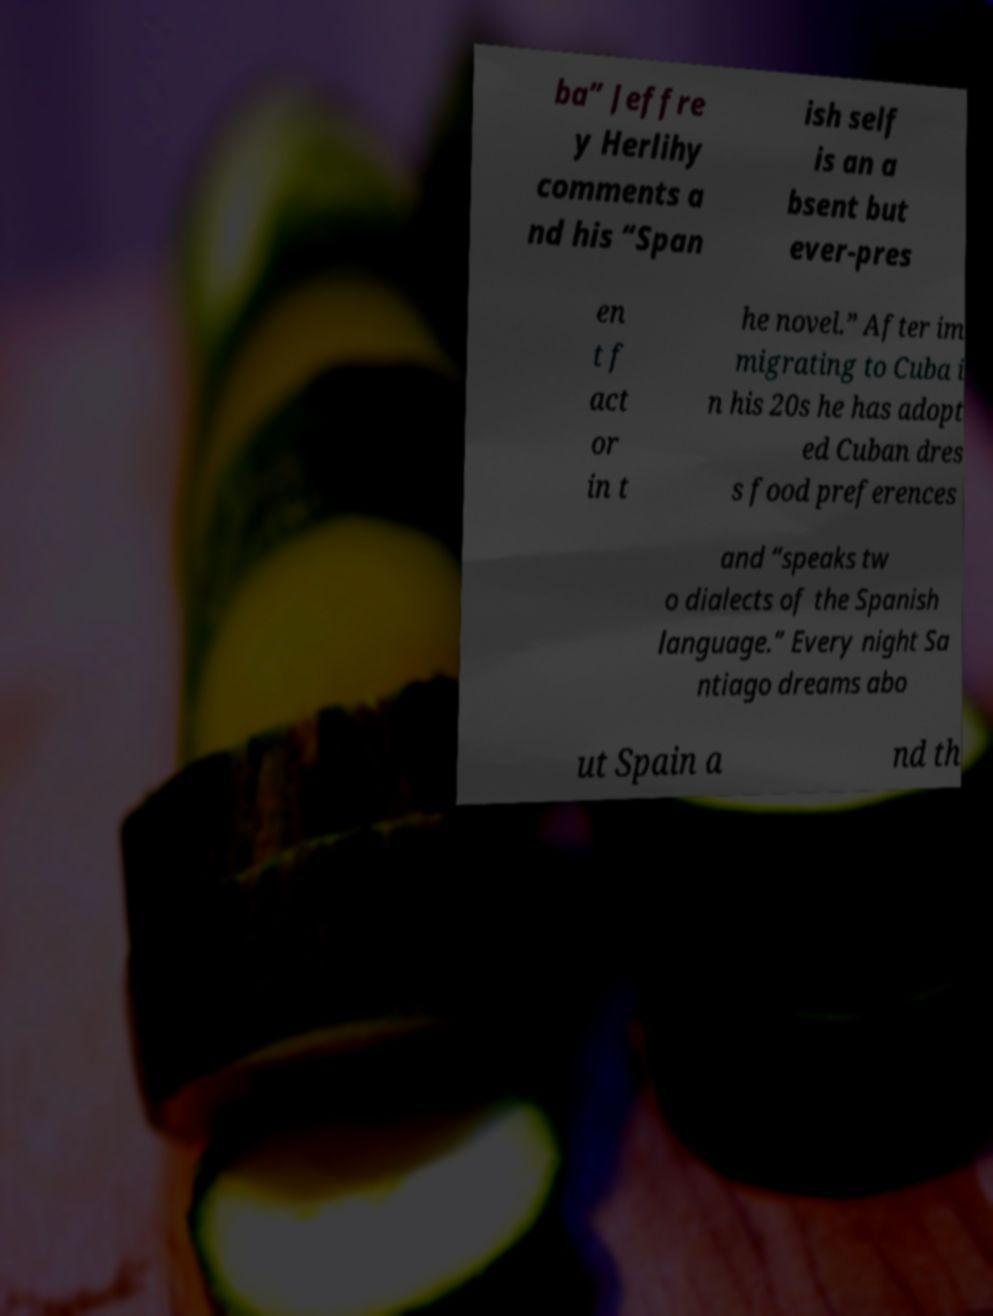What messages or text are displayed in this image? I need them in a readable, typed format. ba” Jeffre y Herlihy comments a nd his “Span ish self is an a bsent but ever-pres en t f act or in t he novel.” After im migrating to Cuba i n his 20s he has adopt ed Cuban dres s food preferences and “speaks tw o dialects of the Spanish language.” Every night Sa ntiago dreams abo ut Spain a nd th 